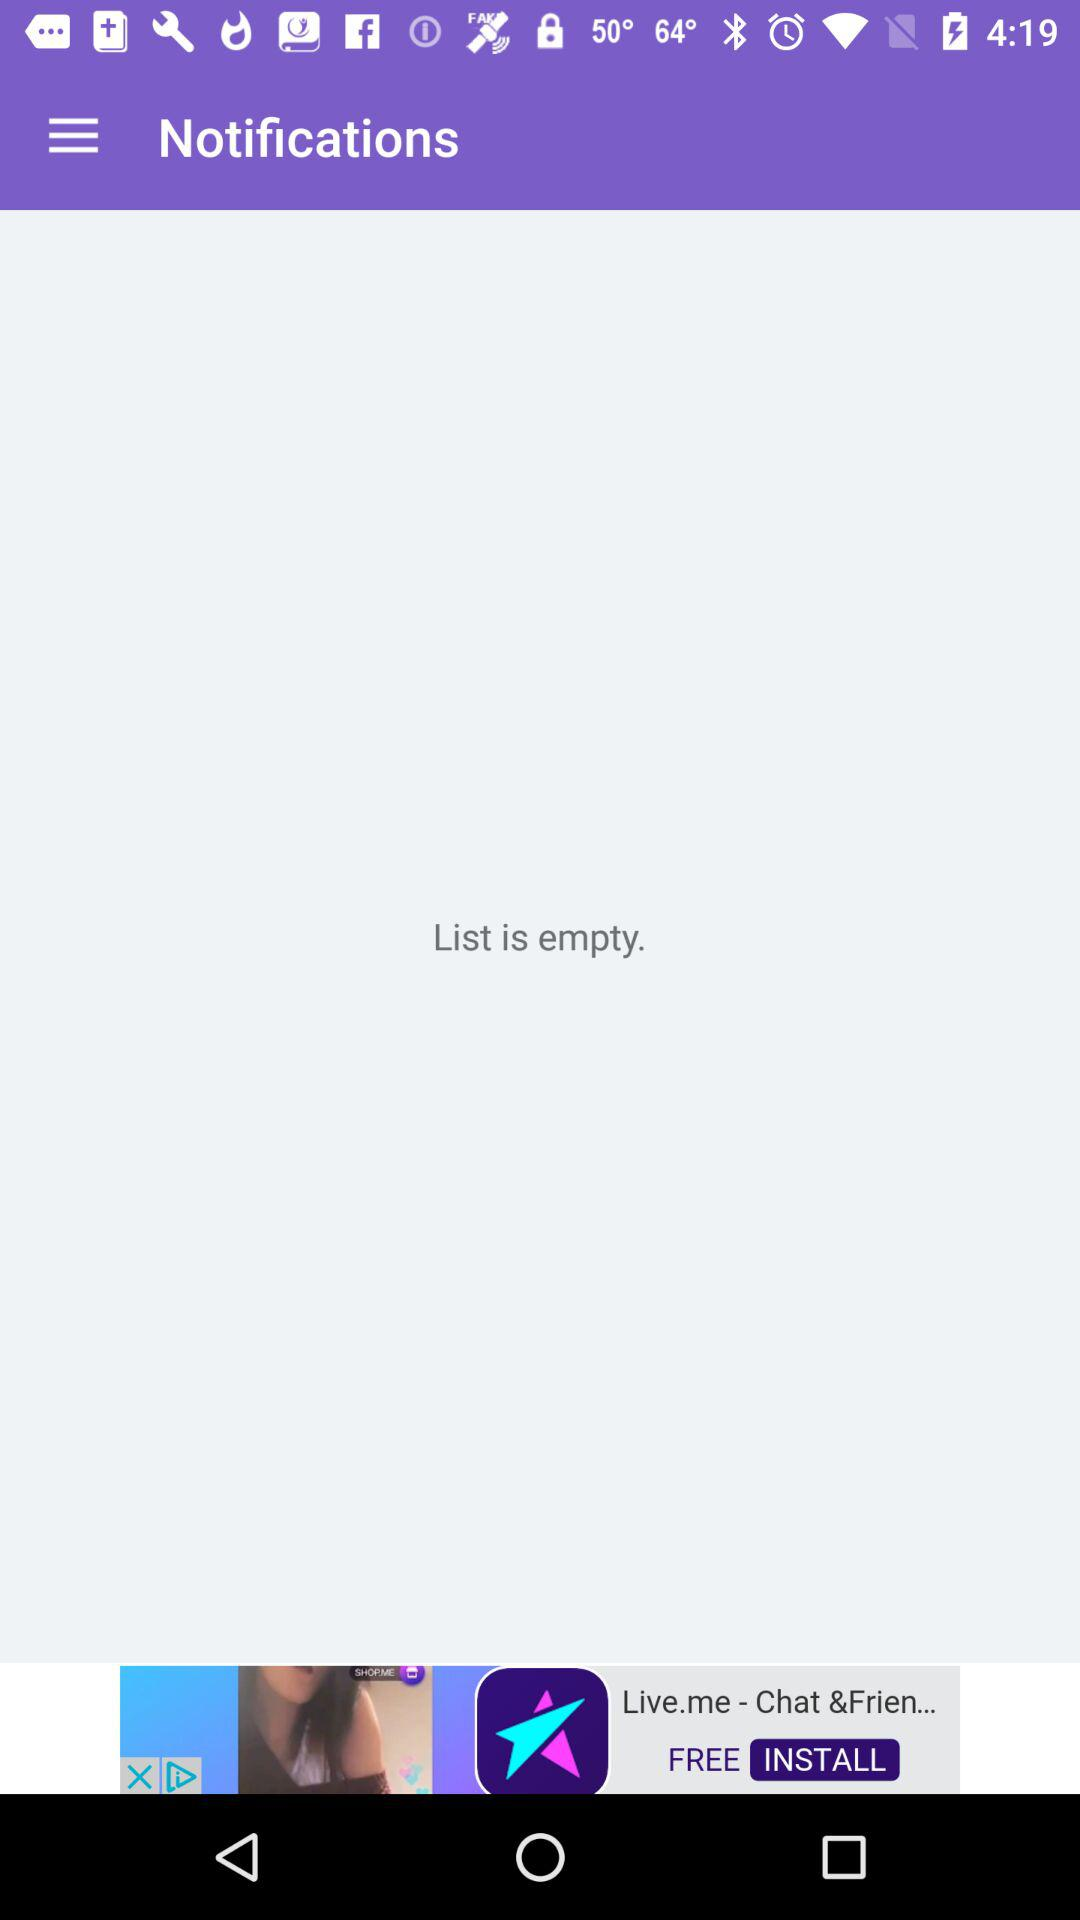Is there any item in the list? The list is empty. 